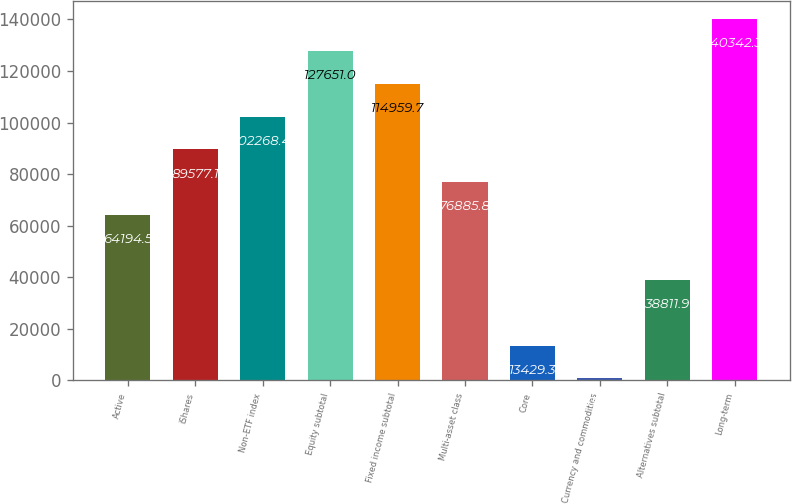Convert chart to OTSL. <chart><loc_0><loc_0><loc_500><loc_500><bar_chart><fcel>Active<fcel>iShares<fcel>Non-ETF index<fcel>Equity subtotal<fcel>Fixed income subtotal<fcel>Multi-asset class<fcel>Core<fcel>Currency and commodities<fcel>Alternatives subtotal<fcel>Long-term<nl><fcel>64194.5<fcel>89577.1<fcel>102268<fcel>127651<fcel>114960<fcel>76885.8<fcel>13429.3<fcel>738<fcel>38811.9<fcel>140342<nl></chart> 